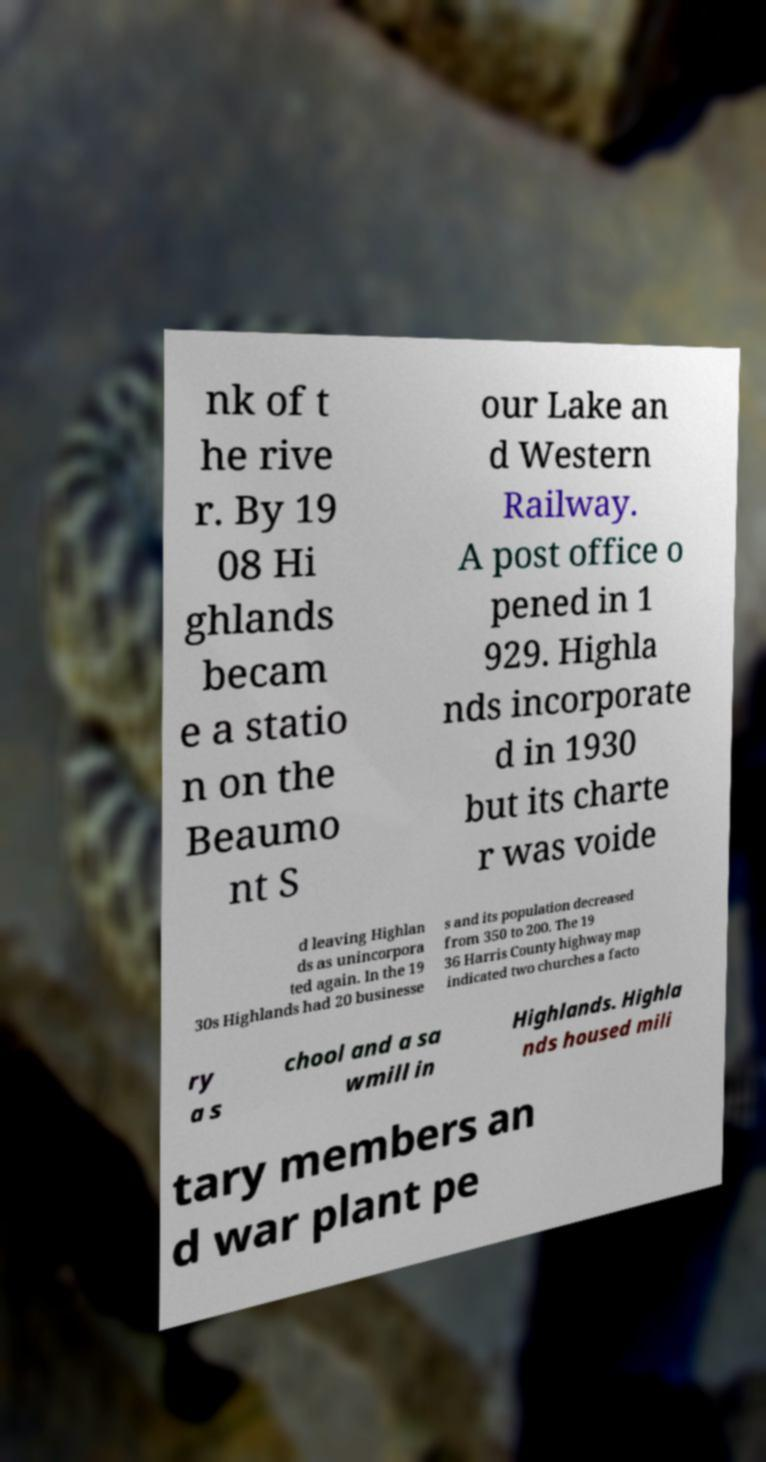There's text embedded in this image that I need extracted. Can you transcribe it verbatim? nk of t he rive r. By 19 08 Hi ghlands becam e a statio n on the Beaumo nt S our Lake an d Western Railway. A post office o pened in 1 929. Highla nds incorporate d in 1930 but its charte r was voide d leaving Highlan ds as unincorpora ted again. In the 19 30s Highlands had 20 businesse s and its population decreased from 350 to 200. The 19 36 Harris County highway map indicated two churches a facto ry a s chool and a sa wmill in Highlands. Highla nds housed mili tary members an d war plant pe 